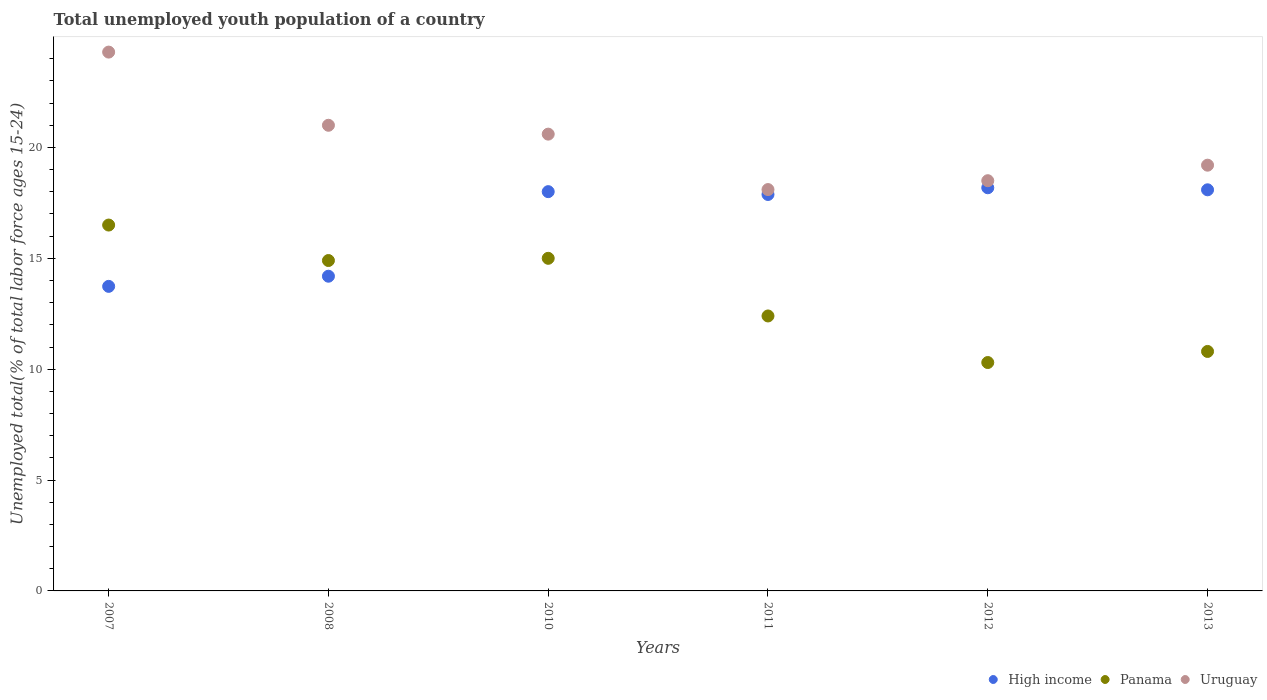What is the percentage of total unemployed youth population of a country in Uruguay in 2013?
Offer a very short reply. 19.2. Across all years, what is the maximum percentage of total unemployed youth population of a country in Panama?
Keep it short and to the point. 16.5. Across all years, what is the minimum percentage of total unemployed youth population of a country in Uruguay?
Provide a succinct answer. 18.1. What is the total percentage of total unemployed youth population of a country in High income in the graph?
Provide a short and direct response. 100.08. What is the difference between the percentage of total unemployed youth population of a country in Uruguay in 2012 and that in 2013?
Offer a terse response. -0.7. What is the difference between the percentage of total unemployed youth population of a country in High income in 2011 and the percentage of total unemployed youth population of a country in Uruguay in 2008?
Make the answer very short. -3.12. What is the average percentage of total unemployed youth population of a country in Panama per year?
Your response must be concise. 13.32. In the year 2007, what is the difference between the percentage of total unemployed youth population of a country in Panama and percentage of total unemployed youth population of a country in High income?
Provide a succinct answer. 2.76. What is the ratio of the percentage of total unemployed youth population of a country in Uruguay in 2010 to that in 2013?
Offer a terse response. 1.07. What is the difference between the highest and the second highest percentage of total unemployed youth population of a country in Panama?
Give a very brief answer. 1.5. What is the difference between the highest and the lowest percentage of total unemployed youth population of a country in Panama?
Your response must be concise. 6.2. In how many years, is the percentage of total unemployed youth population of a country in High income greater than the average percentage of total unemployed youth population of a country in High income taken over all years?
Your answer should be compact. 4. Is it the case that in every year, the sum of the percentage of total unemployed youth population of a country in High income and percentage of total unemployed youth population of a country in Uruguay  is greater than the percentage of total unemployed youth population of a country in Panama?
Your answer should be very brief. Yes. Does the percentage of total unemployed youth population of a country in Panama monotonically increase over the years?
Give a very brief answer. No. Is the percentage of total unemployed youth population of a country in High income strictly greater than the percentage of total unemployed youth population of a country in Uruguay over the years?
Ensure brevity in your answer.  No. Is the percentage of total unemployed youth population of a country in Panama strictly less than the percentage of total unemployed youth population of a country in Uruguay over the years?
Provide a short and direct response. Yes. How many years are there in the graph?
Offer a terse response. 6. What is the difference between two consecutive major ticks on the Y-axis?
Your answer should be very brief. 5. Does the graph contain any zero values?
Ensure brevity in your answer.  No. How many legend labels are there?
Ensure brevity in your answer.  3. How are the legend labels stacked?
Offer a terse response. Horizontal. What is the title of the graph?
Provide a succinct answer. Total unemployed youth population of a country. What is the label or title of the Y-axis?
Your answer should be very brief. Unemployed total(% of total labor force ages 15-24). What is the Unemployed total(% of total labor force ages 15-24) of High income in 2007?
Your response must be concise. 13.74. What is the Unemployed total(% of total labor force ages 15-24) of Panama in 2007?
Make the answer very short. 16.5. What is the Unemployed total(% of total labor force ages 15-24) of Uruguay in 2007?
Provide a succinct answer. 24.3. What is the Unemployed total(% of total labor force ages 15-24) in High income in 2008?
Your answer should be very brief. 14.19. What is the Unemployed total(% of total labor force ages 15-24) of Panama in 2008?
Offer a terse response. 14.9. What is the Unemployed total(% of total labor force ages 15-24) in Uruguay in 2008?
Make the answer very short. 21. What is the Unemployed total(% of total labor force ages 15-24) in High income in 2010?
Provide a short and direct response. 18.01. What is the Unemployed total(% of total labor force ages 15-24) of Uruguay in 2010?
Offer a terse response. 20.6. What is the Unemployed total(% of total labor force ages 15-24) of High income in 2011?
Offer a terse response. 17.88. What is the Unemployed total(% of total labor force ages 15-24) of Panama in 2011?
Make the answer very short. 12.4. What is the Unemployed total(% of total labor force ages 15-24) in Uruguay in 2011?
Keep it short and to the point. 18.1. What is the Unemployed total(% of total labor force ages 15-24) in High income in 2012?
Offer a terse response. 18.18. What is the Unemployed total(% of total labor force ages 15-24) in Panama in 2012?
Give a very brief answer. 10.3. What is the Unemployed total(% of total labor force ages 15-24) in Uruguay in 2012?
Ensure brevity in your answer.  18.5. What is the Unemployed total(% of total labor force ages 15-24) in High income in 2013?
Your answer should be very brief. 18.09. What is the Unemployed total(% of total labor force ages 15-24) in Panama in 2013?
Make the answer very short. 10.8. What is the Unemployed total(% of total labor force ages 15-24) of Uruguay in 2013?
Offer a terse response. 19.2. Across all years, what is the maximum Unemployed total(% of total labor force ages 15-24) of High income?
Ensure brevity in your answer.  18.18. Across all years, what is the maximum Unemployed total(% of total labor force ages 15-24) in Uruguay?
Offer a very short reply. 24.3. Across all years, what is the minimum Unemployed total(% of total labor force ages 15-24) of High income?
Your answer should be very brief. 13.74. Across all years, what is the minimum Unemployed total(% of total labor force ages 15-24) of Panama?
Provide a short and direct response. 10.3. Across all years, what is the minimum Unemployed total(% of total labor force ages 15-24) of Uruguay?
Keep it short and to the point. 18.1. What is the total Unemployed total(% of total labor force ages 15-24) in High income in the graph?
Provide a short and direct response. 100.08. What is the total Unemployed total(% of total labor force ages 15-24) in Panama in the graph?
Make the answer very short. 79.9. What is the total Unemployed total(% of total labor force ages 15-24) in Uruguay in the graph?
Your response must be concise. 121.7. What is the difference between the Unemployed total(% of total labor force ages 15-24) of High income in 2007 and that in 2008?
Give a very brief answer. -0.46. What is the difference between the Unemployed total(% of total labor force ages 15-24) in High income in 2007 and that in 2010?
Provide a short and direct response. -4.27. What is the difference between the Unemployed total(% of total labor force ages 15-24) in High income in 2007 and that in 2011?
Make the answer very short. -4.14. What is the difference between the Unemployed total(% of total labor force ages 15-24) of Uruguay in 2007 and that in 2011?
Ensure brevity in your answer.  6.2. What is the difference between the Unemployed total(% of total labor force ages 15-24) of High income in 2007 and that in 2012?
Offer a very short reply. -4.45. What is the difference between the Unemployed total(% of total labor force ages 15-24) of Panama in 2007 and that in 2012?
Ensure brevity in your answer.  6.2. What is the difference between the Unemployed total(% of total labor force ages 15-24) of Uruguay in 2007 and that in 2012?
Ensure brevity in your answer.  5.8. What is the difference between the Unemployed total(% of total labor force ages 15-24) in High income in 2007 and that in 2013?
Your answer should be compact. -4.35. What is the difference between the Unemployed total(% of total labor force ages 15-24) in Uruguay in 2007 and that in 2013?
Your response must be concise. 5.1. What is the difference between the Unemployed total(% of total labor force ages 15-24) of High income in 2008 and that in 2010?
Keep it short and to the point. -3.81. What is the difference between the Unemployed total(% of total labor force ages 15-24) of Panama in 2008 and that in 2010?
Offer a terse response. -0.1. What is the difference between the Unemployed total(% of total labor force ages 15-24) in High income in 2008 and that in 2011?
Give a very brief answer. -3.69. What is the difference between the Unemployed total(% of total labor force ages 15-24) of High income in 2008 and that in 2012?
Ensure brevity in your answer.  -3.99. What is the difference between the Unemployed total(% of total labor force ages 15-24) in Panama in 2008 and that in 2012?
Ensure brevity in your answer.  4.6. What is the difference between the Unemployed total(% of total labor force ages 15-24) of Uruguay in 2008 and that in 2012?
Give a very brief answer. 2.5. What is the difference between the Unemployed total(% of total labor force ages 15-24) of High income in 2008 and that in 2013?
Your answer should be very brief. -3.9. What is the difference between the Unemployed total(% of total labor force ages 15-24) of Uruguay in 2008 and that in 2013?
Your answer should be compact. 1.8. What is the difference between the Unemployed total(% of total labor force ages 15-24) of High income in 2010 and that in 2011?
Offer a terse response. 0.13. What is the difference between the Unemployed total(% of total labor force ages 15-24) in Panama in 2010 and that in 2011?
Offer a terse response. 2.6. What is the difference between the Unemployed total(% of total labor force ages 15-24) in Uruguay in 2010 and that in 2011?
Your answer should be compact. 2.5. What is the difference between the Unemployed total(% of total labor force ages 15-24) in High income in 2010 and that in 2012?
Your answer should be very brief. -0.18. What is the difference between the Unemployed total(% of total labor force ages 15-24) in Uruguay in 2010 and that in 2012?
Your answer should be very brief. 2.1. What is the difference between the Unemployed total(% of total labor force ages 15-24) of High income in 2010 and that in 2013?
Your response must be concise. -0.08. What is the difference between the Unemployed total(% of total labor force ages 15-24) of Panama in 2010 and that in 2013?
Your response must be concise. 4.2. What is the difference between the Unemployed total(% of total labor force ages 15-24) of Uruguay in 2010 and that in 2013?
Provide a short and direct response. 1.4. What is the difference between the Unemployed total(% of total labor force ages 15-24) of High income in 2011 and that in 2012?
Make the answer very short. -0.3. What is the difference between the Unemployed total(% of total labor force ages 15-24) of Uruguay in 2011 and that in 2012?
Keep it short and to the point. -0.4. What is the difference between the Unemployed total(% of total labor force ages 15-24) in High income in 2011 and that in 2013?
Offer a very short reply. -0.21. What is the difference between the Unemployed total(% of total labor force ages 15-24) of Uruguay in 2011 and that in 2013?
Offer a terse response. -1.1. What is the difference between the Unemployed total(% of total labor force ages 15-24) of High income in 2012 and that in 2013?
Your answer should be compact. 0.09. What is the difference between the Unemployed total(% of total labor force ages 15-24) of High income in 2007 and the Unemployed total(% of total labor force ages 15-24) of Panama in 2008?
Provide a succinct answer. -1.16. What is the difference between the Unemployed total(% of total labor force ages 15-24) of High income in 2007 and the Unemployed total(% of total labor force ages 15-24) of Uruguay in 2008?
Your response must be concise. -7.26. What is the difference between the Unemployed total(% of total labor force ages 15-24) in High income in 2007 and the Unemployed total(% of total labor force ages 15-24) in Panama in 2010?
Make the answer very short. -1.26. What is the difference between the Unemployed total(% of total labor force ages 15-24) of High income in 2007 and the Unemployed total(% of total labor force ages 15-24) of Uruguay in 2010?
Ensure brevity in your answer.  -6.86. What is the difference between the Unemployed total(% of total labor force ages 15-24) in Panama in 2007 and the Unemployed total(% of total labor force ages 15-24) in Uruguay in 2010?
Keep it short and to the point. -4.1. What is the difference between the Unemployed total(% of total labor force ages 15-24) of High income in 2007 and the Unemployed total(% of total labor force ages 15-24) of Panama in 2011?
Give a very brief answer. 1.34. What is the difference between the Unemployed total(% of total labor force ages 15-24) of High income in 2007 and the Unemployed total(% of total labor force ages 15-24) of Uruguay in 2011?
Keep it short and to the point. -4.36. What is the difference between the Unemployed total(% of total labor force ages 15-24) in Panama in 2007 and the Unemployed total(% of total labor force ages 15-24) in Uruguay in 2011?
Provide a short and direct response. -1.6. What is the difference between the Unemployed total(% of total labor force ages 15-24) in High income in 2007 and the Unemployed total(% of total labor force ages 15-24) in Panama in 2012?
Make the answer very short. 3.44. What is the difference between the Unemployed total(% of total labor force ages 15-24) in High income in 2007 and the Unemployed total(% of total labor force ages 15-24) in Uruguay in 2012?
Provide a succinct answer. -4.76. What is the difference between the Unemployed total(% of total labor force ages 15-24) in High income in 2007 and the Unemployed total(% of total labor force ages 15-24) in Panama in 2013?
Your answer should be compact. 2.94. What is the difference between the Unemployed total(% of total labor force ages 15-24) in High income in 2007 and the Unemployed total(% of total labor force ages 15-24) in Uruguay in 2013?
Your answer should be compact. -5.46. What is the difference between the Unemployed total(% of total labor force ages 15-24) of High income in 2008 and the Unemployed total(% of total labor force ages 15-24) of Panama in 2010?
Provide a short and direct response. -0.81. What is the difference between the Unemployed total(% of total labor force ages 15-24) in High income in 2008 and the Unemployed total(% of total labor force ages 15-24) in Uruguay in 2010?
Make the answer very short. -6.41. What is the difference between the Unemployed total(% of total labor force ages 15-24) of Panama in 2008 and the Unemployed total(% of total labor force ages 15-24) of Uruguay in 2010?
Your answer should be compact. -5.7. What is the difference between the Unemployed total(% of total labor force ages 15-24) of High income in 2008 and the Unemployed total(% of total labor force ages 15-24) of Panama in 2011?
Keep it short and to the point. 1.79. What is the difference between the Unemployed total(% of total labor force ages 15-24) of High income in 2008 and the Unemployed total(% of total labor force ages 15-24) of Uruguay in 2011?
Provide a succinct answer. -3.91. What is the difference between the Unemployed total(% of total labor force ages 15-24) of High income in 2008 and the Unemployed total(% of total labor force ages 15-24) of Panama in 2012?
Offer a terse response. 3.89. What is the difference between the Unemployed total(% of total labor force ages 15-24) of High income in 2008 and the Unemployed total(% of total labor force ages 15-24) of Uruguay in 2012?
Give a very brief answer. -4.31. What is the difference between the Unemployed total(% of total labor force ages 15-24) of Panama in 2008 and the Unemployed total(% of total labor force ages 15-24) of Uruguay in 2012?
Give a very brief answer. -3.6. What is the difference between the Unemployed total(% of total labor force ages 15-24) of High income in 2008 and the Unemployed total(% of total labor force ages 15-24) of Panama in 2013?
Your response must be concise. 3.39. What is the difference between the Unemployed total(% of total labor force ages 15-24) in High income in 2008 and the Unemployed total(% of total labor force ages 15-24) in Uruguay in 2013?
Make the answer very short. -5.01. What is the difference between the Unemployed total(% of total labor force ages 15-24) of Panama in 2008 and the Unemployed total(% of total labor force ages 15-24) of Uruguay in 2013?
Offer a terse response. -4.3. What is the difference between the Unemployed total(% of total labor force ages 15-24) of High income in 2010 and the Unemployed total(% of total labor force ages 15-24) of Panama in 2011?
Give a very brief answer. 5.61. What is the difference between the Unemployed total(% of total labor force ages 15-24) in High income in 2010 and the Unemployed total(% of total labor force ages 15-24) in Uruguay in 2011?
Provide a succinct answer. -0.09. What is the difference between the Unemployed total(% of total labor force ages 15-24) in High income in 2010 and the Unemployed total(% of total labor force ages 15-24) in Panama in 2012?
Provide a succinct answer. 7.71. What is the difference between the Unemployed total(% of total labor force ages 15-24) in High income in 2010 and the Unemployed total(% of total labor force ages 15-24) in Uruguay in 2012?
Make the answer very short. -0.49. What is the difference between the Unemployed total(% of total labor force ages 15-24) of Panama in 2010 and the Unemployed total(% of total labor force ages 15-24) of Uruguay in 2012?
Make the answer very short. -3.5. What is the difference between the Unemployed total(% of total labor force ages 15-24) in High income in 2010 and the Unemployed total(% of total labor force ages 15-24) in Panama in 2013?
Give a very brief answer. 7.21. What is the difference between the Unemployed total(% of total labor force ages 15-24) of High income in 2010 and the Unemployed total(% of total labor force ages 15-24) of Uruguay in 2013?
Give a very brief answer. -1.19. What is the difference between the Unemployed total(% of total labor force ages 15-24) in Panama in 2010 and the Unemployed total(% of total labor force ages 15-24) in Uruguay in 2013?
Provide a succinct answer. -4.2. What is the difference between the Unemployed total(% of total labor force ages 15-24) in High income in 2011 and the Unemployed total(% of total labor force ages 15-24) in Panama in 2012?
Your answer should be very brief. 7.58. What is the difference between the Unemployed total(% of total labor force ages 15-24) of High income in 2011 and the Unemployed total(% of total labor force ages 15-24) of Uruguay in 2012?
Offer a very short reply. -0.62. What is the difference between the Unemployed total(% of total labor force ages 15-24) in High income in 2011 and the Unemployed total(% of total labor force ages 15-24) in Panama in 2013?
Your answer should be very brief. 7.08. What is the difference between the Unemployed total(% of total labor force ages 15-24) of High income in 2011 and the Unemployed total(% of total labor force ages 15-24) of Uruguay in 2013?
Make the answer very short. -1.32. What is the difference between the Unemployed total(% of total labor force ages 15-24) in High income in 2012 and the Unemployed total(% of total labor force ages 15-24) in Panama in 2013?
Provide a succinct answer. 7.38. What is the difference between the Unemployed total(% of total labor force ages 15-24) of High income in 2012 and the Unemployed total(% of total labor force ages 15-24) of Uruguay in 2013?
Provide a succinct answer. -1.02. What is the difference between the Unemployed total(% of total labor force ages 15-24) in Panama in 2012 and the Unemployed total(% of total labor force ages 15-24) in Uruguay in 2013?
Provide a succinct answer. -8.9. What is the average Unemployed total(% of total labor force ages 15-24) in High income per year?
Provide a succinct answer. 16.68. What is the average Unemployed total(% of total labor force ages 15-24) of Panama per year?
Ensure brevity in your answer.  13.32. What is the average Unemployed total(% of total labor force ages 15-24) of Uruguay per year?
Your answer should be compact. 20.28. In the year 2007, what is the difference between the Unemployed total(% of total labor force ages 15-24) of High income and Unemployed total(% of total labor force ages 15-24) of Panama?
Offer a terse response. -2.76. In the year 2007, what is the difference between the Unemployed total(% of total labor force ages 15-24) of High income and Unemployed total(% of total labor force ages 15-24) of Uruguay?
Provide a short and direct response. -10.56. In the year 2008, what is the difference between the Unemployed total(% of total labor force ages 15-24) of High income and Unemployed total(% of total labor force ages 15-24) of Panama?
Ensure brevity in your answer.  -0.71. In the year 2008, what is the difference between the Unemployed total(% of total labor force ages 15-24) of High income and Unemployed total(% of total labor force ages 15-24) of Uruguay?
Offer a terse response. -6.81. In the year 2008, what is the difference between the Unemployed total(% of total labor force ages 15-24) of Panama and Unemployed total(% of total labor force ages 15-24) of Uruguay?
Provide a succinct answer. -6.1. In the year 2010, what is the difference between the Unemployed total(% of total labor force ages 15-24) in High income and Unemployed total(% of total labor force ages 15-24) in Panama?
Your response must be concise. 3.01. In the year 2010, what is the difference between the Unemployed total(% of total labor force ages 15-24) of High income and Unemployed total(% of total labor force ages 15-24) of Uruguay?
Your answer should be very brief. -2.59. In the year 2011, what is the difference between the Unemployed total(% of total labor force ages 15-24) of High income and Unemployed total(% of total labor force ages 15-24) of Panama?
Provide a succinct answer. 5.48. In the year 2011, what is the difference between the Unemployed total(% of total labor force ages 15-24) in High income and Unemployed total(% of total labor force ages 15-24) in Uruguay?
Make the answer very short. -0.22. In the year 2012, what is the difference between the Unemployed total(% of total labor force ages 15-24) of High income and Unemployed total(% of total labor force ages 15-24) of Panama?
Ensure brevity in your answer.  7.88. In the year 2012, what is the difference between the Unemployed total(% of total labor force ages 15-24) in High income and Unemployed total(% of total labor force ages 15-24) in Uruguay?
Offer a terse response. -0.32. In the year 2013, what is the difference between the Unemployed total(% of total labor force ages 15-24) of High income and Unemployed total(% of total labor force ages 15-24) of Panama?
Keep it short and to the point. 7.29. In the year 2013, what is the difference between the Unemployed total(% of total labor force ages 15-24) of High income and Unemployed total(% of total labor force ages 15-24) of Uruguay?
Your answer should be compact. -1.11. What is the ratio of the Unemployed total(% of total labor force ages 15-24) of High income in 2007 to that in 2008?
Ensure brevity in your answer.  0.97. What is the ratio of the Unemployed total(% of total labor force ages 15-24) in Panama in 2007 to that in 2008?
Make the answer very short. 1.11. What is the ratio of the Unemployed total(% of total labor force ages 15-24) of Uruguay in 2007 to that in 2008?
Your answer should be very brief. 1.16. What is the ratio of the Unemployed total(% of total labor force ages 15-24) in High income in 2007 to that in 2010?
Ensure brevity in your answer.  0.76. What is the ratio of the Unemployed total(% of total labor force ages 15-24) in Panama in 2007 to that in 2010?
Give a very brief answer. 1.1. What is the ratio of the Unemployed total(% of total labor force ages 15-24) of Uruguay in 2007 to that in 2010?
Keep it short and to the point. 1.18. What is the ratio of the Unemployed total(% of total labor force ages 15-24) of High income in 2007 to that in 2011?
Give a very brief answer. 0.77. What is the ratio of the Unemployed total(% of total labor force ages 15-24) in Panama in 2007 to that in 2011?
Your answer should be compact. 1.33. What is the ratio of the Unemployed total(% of total labor force ages 15-24) in Uruguay in 2007 to that in 2011?
Offer a very short reply. 1.34. What is the ratio of the Unemployed total(% of total labor force ages 15-24) of High income in 2007 to that in 2012?
Give a very brief answer. 0.76. What is the ratio of the Unemployed total(% of total labor force ages 15-24) of Panama in 2007 to that in 2012?
Offer a very short reply. 1.6. What is the ratio of the Unemployed total(% of total labor force ages 15-24) in Uruguay in 2007 to that in 2012?
Your answer should be compact. 1.31. What is the ratio of the Unemployed total(% of total labor force ages 15-24) of High income in 2007 to that in 2013?
Your response must be concise. 0.76. What is the ratio of the Unemployed total(% of total labor force ages 15-24) in Panama in 2007 to that in 2013?
Ensure brevity in your answer.  1.53. What is the ratio of the Unemployed total(% of total labor force ages 15-24) of Uruguay in 2007 to that in 2013?
Your answer should be compact. 1.27. What is the ratio of the Unemployed total(% of total labor force ages 15-24) in High income in 2008 to that in 2010?
Your answer should be very brief. 0.79. What is the ratio of the Unemployed total(% of total labor force ages 15-24) of Panama in 2008 to that in 2010?
Your response must be concise. 0.99. What is the ratio of the Unemployed total(% of total labor force ages 15-24) of Uruguay in 2008 to that in 2010?
Provide a short and direct response. 1.02. What is the ratio of the Unemployed total(% of total labor force ages 15-24) of High income in 2008 to that in 2011?
Provide a succinct answer. 0.79. What is the ratio of the Unemployed total(% of total labor force ages 15-24) of Panama in 2008 to that in 2011?
Offer a terse response. 1.2. What is the ratio of the Unemployed total(% of total labor force ages 15-24) in Uruguay in 2008 to that in 2011?
Offer a very short reply. 1.16. What is the ratio of the Unemployed total(% of total labor force ages 15-24) of High income in 2008 to that in 2012?
Offer a terse response. 0.78. What is the ratio of the Unemployed total(% of total labor force ages 15-24) of Panama in 2008 to that in 2012?
Keep it short and to the point. 1.45. What is the ratio of the Unemployed total(% of total labor force ages 15-24) of Uruguay in 2008 to that in 2012?
Ensure brevity in your answer.  1.14. What is the ratio of the Unemployed total(% of total labor force ages 15-24) in High income in 2008 to that in 2013?
Your answer should be very brief. 0.78. What is the ratio of the Unemployed total(% of total labor force ages 15-24) in Panama in 2008 to that in 2013?
Provide a succinct answer. 1.38. What is the ratio of the Unemployed total(% of total labor force ages 15-24) in Uruguay in 2008 to that in 2013?
Make the answer very short. 1.09. What is the ratio of the Unemployed total(% of total labor force ages 15-24) of High income in 2010 to that in 2011?
Give a very brief answer. 1.01. What is the ratio of the Unemployed total(% of total labor force ages 15-24) in Panama in 2010 to that in 2011?
Give a very brief answer. 1.21. What is the ratio of the Unemployed total(% of total labor force ages 15-24) in Uruguay in 2010 to that in 2011?
Give a very brief answer. 1.14. What is the ratio of the Unemployed total(% of total labor force ages 15-24) of High income in 2010 to that in 2012?
Your answer should be compact. 0.99. What is the ratio of the Unemployed total(% of total labor force ages 15-24) of Panama in 2010 to that in 2012?
Give a very brief answer. 1.46. What is the ratio of the Unemployed total(% of total labor force ages 15-24) of Uruguay in 2010 to that in 2012?
Ensure brevity in your answer.  1.11. What is the ratio of the Unemployed total(% of total labor force ages 15-24) of High income in 2010 to that in 2013?
Give a very brief answer. 1. What is the ratio of the Unemployed total(% of total labor force ages 15-24) in Panama in 2010 to that in 2013?
Make the answer very short. 1.39. What is the ratio of the Unemployed total(% of total labor force ages 15-24) of Uruguay in 2010 to that in 2013?
Keep it short and to the point. 1.07. What is the ratio of the Unemployed total(% of total labor force ages 15-24) of High income in 2011 to that in 2012?
Your response must be concise. 0.98. What is the ratio of the Unemployed total(% of total labor force ages 15-24) in Panama in 2011 to that in 2012?
Your answer should be compact. 1.2. What is the ratio of the Unemployed total(% of total labor force ages 15-24) in Uruguay in 2011 to that in 2012?
Offer a very short reply. 0.98. What is the ratio of the Unemployed total(% of total labor force ages 15-24) in High income in 2011 to that in 2013?
Give a very brief answer. 0.99. What is the ratio of the Unemployed total(% of total labor force ages 15-24) in Panama in 2011 to that in 2013?
Make the answer very short. 1.15. What is the ratio of the Unemployed total(% of total labor force ages 15-24) of Uruguay in 2011 to that in 2013?
Your answer should be very brief. 0.94. What is the ratio of the Unemployed total(% of total labor force ages 15-24) in Panama in 2012 to that in 2013?
Give a very brief answer. 0.95. What is the ratio of the Unemployed total(% of total labor force ages 15-24) in Uruguay in 2012 to that in 2013?
Make the answer very short. 0.96. What is the difference between the highest and the second highest Unemployed total(% of total labor force ages 15-24) of High income?
Give a very brief answer. 0.09. What is the difference between the highest and the second highest Unemployed total(% of total labor force ages 15-24) of Uruguay?
Your response must be concise. 3.3. What is the difference between the highest and the lowest Unemployed total(% of total labor force ages 15-24) in High income?
Your answer should be compact. 4.45. What is the difference between the highest and the lowest Unemployed total(% of total labor force ages 15-24) of Uruguay?
Provide a short and direct response. 6.2. 